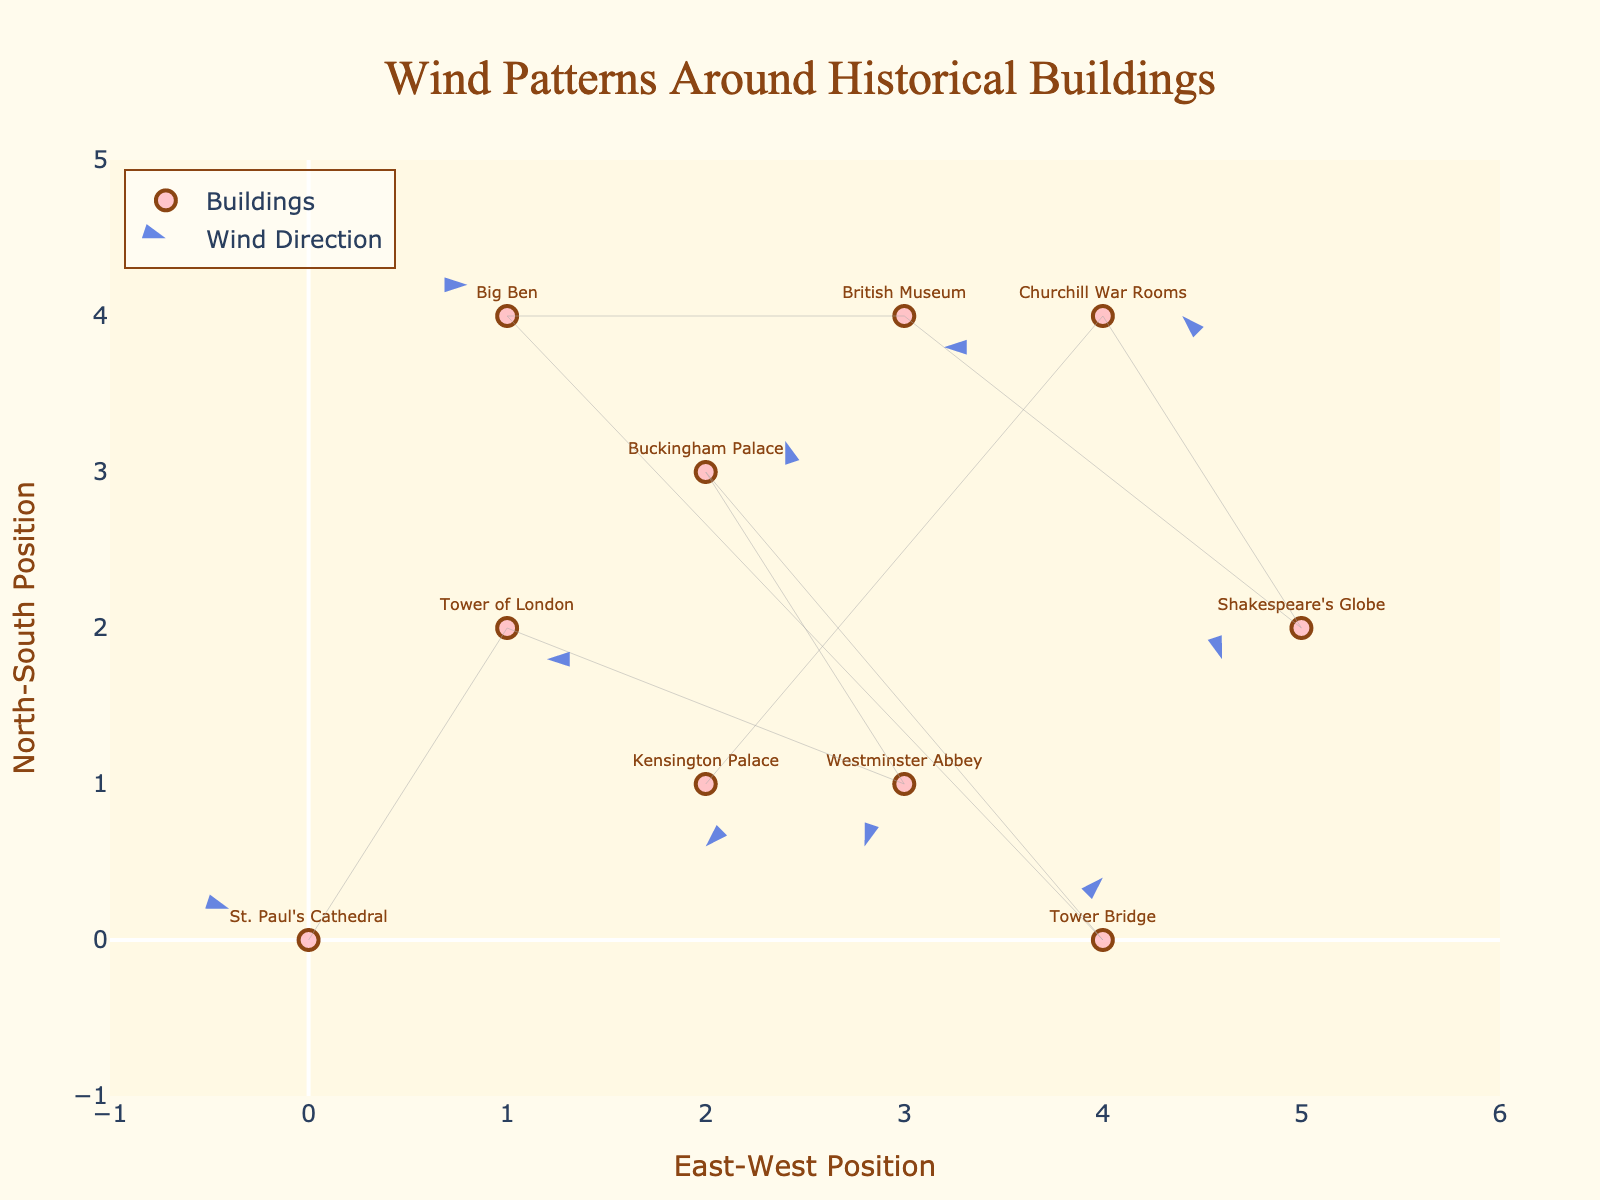What's the title of the plot? The title of the plot is shown at the top center of the figure.
Answer: Wind Patterns Around Historical Buildings How many historical buildings are shown on the plot? Each point on the plot represents a different historical building; count the number of points and labels. There are 10 labels.
Answer: 10 Which building has the strongest southward wind direction? Look for the arrow pointing most directly down and with the longest length. Westminster Abbey's vector (-1, -2) indicates strong southward movement.
Answer: Westminster Abbey Which building is positioned furthest to the east? Find the x-coordinate that has the highest value. Tower Bridge (x = 4) and Shakespeare's Globe (x = 5); Shakespeare's Globe is further east.
Answer: Shakespeare's Globe Which buildings have no wind direction (i.e., arrow does not point)? Arrows whose vectors (u,v) are zero indicate no specific wind direction. Check the arrows. Tower Bridge has (0,2) in only the y-direction.
Answer: Tower Bridge Between which two buildings is the difference in wind vector magnitude the greatest? Calculate the vector magnitudes (u^2 + v^2) for each building and find the two with the greatest difference.
Answer: Westminster Abbey and Buckingham Palace What's the most common wind direction among these buildings? Look at the arrows' general directions and identify the most frequent one. Many arrows point diagonally, but more to the left.
Answer: Southwest Is there any correlation between the buildings’ positions and wind direction? Determine if a pattern exists between the buildings' coordinates (x, y) and their wind vectors (u, v).
Answer: No clear pattern Which building experiences wind predominantly in the eastward direction? Identify arrows pointing right (positive u) and check the labels. Buckingham Palace (x=2, y=3, u=2, v=1).
Answer: Buckingham Palace How does the wind at Westminster Abbey differ from the wind at Kensington Palace? Compare the vector values (u, v) between the two buildings. Westminster Abbey: (-1, -2), Kensington Palace: (0, -2). The main difference is the eastward component; Kensington has none.
Answer: Westminster Abbey has southwest, Kensington Palace strictly south 